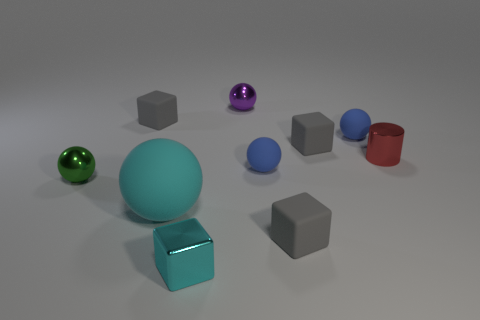Is there a color that appears more than once in the objects? Yes, the color blue appears in three different objects: one cube, one sphere, and one cylindrical object. 